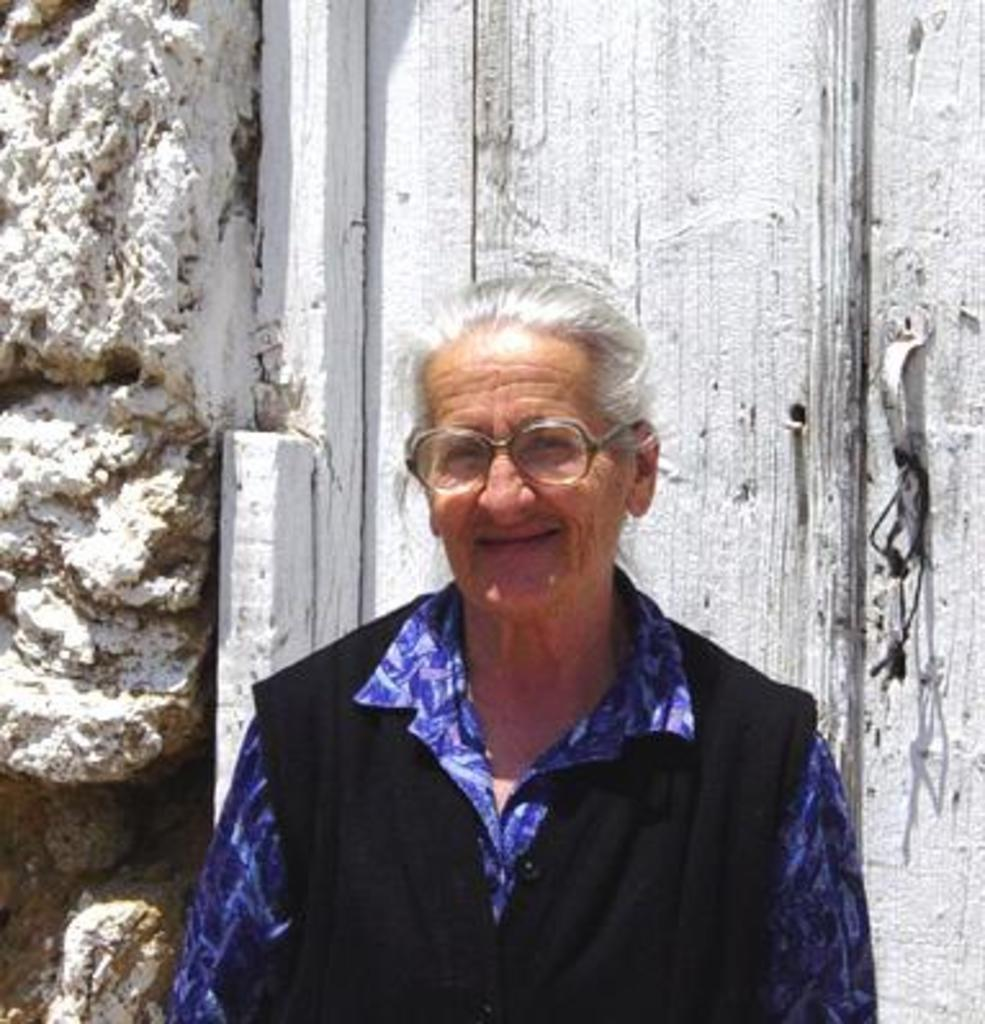What can be seen in the image? There is a person in the image. Can you describe the person's attire? The person is wearing a blue and black color dress. What is visible in the background of the image? There is a rock and a wooden object in the background of the image. How is the wooden object colored? The wooden object is in white color. What type of pancake is being served on the table in the image? There is no table or pancake present in the image. 